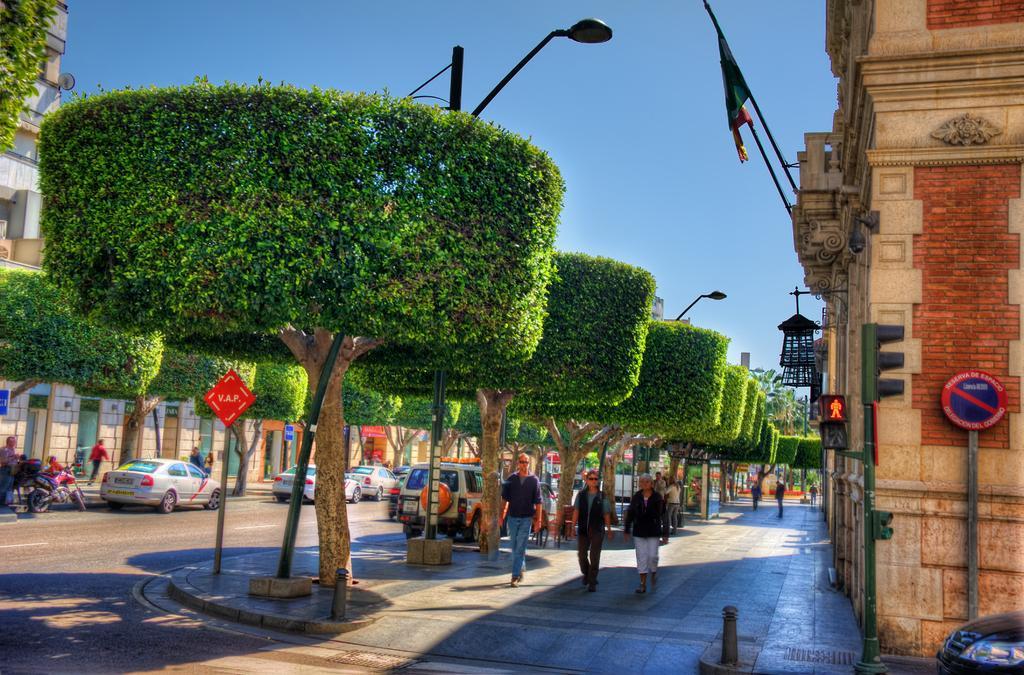In one or two sentences, can you explain what this image depicts? In this image we can see a few people, there are buildings, sign boards, light poles, vehicles and motorcycle on the road, also we can see trees, and the sky. 